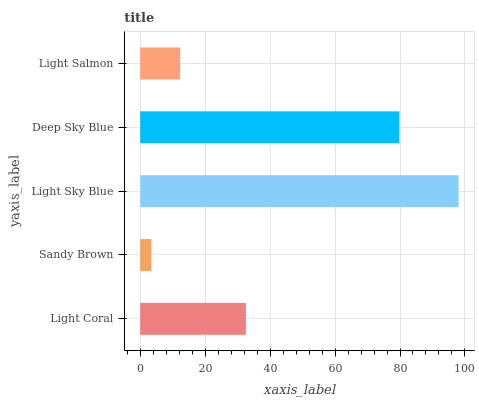Is Sandy Brown the minimum?
Answer yes or no. Yes. Is Light Sky Blue the maximum?
Answer yes or no. Yes. Is Light Sky Blue the minimum?
Answer yes or no. No. Is Sandy Brown the maximum?
Answer yes or no. No. Is Light Sky Blue greater than Sandy Brown?
Answer yes or no. Yes. Is Sandy Brown less than Light Sky Blue?
Answer yes or no. Yes. Is Sandy Brown greater than Light Sky Blue?
Answer yes or no. No. Is Light Sky Blue less than Sandy Brown?
Answer yes or no. No. Is Light Coral the high median?
Answer yes or no. Yes. Is Light Coral the low median?
Answer yes or no. Yes. Is Light Salmon the high median?
Answer yes or no. No. Is Light Sky Blue the low median?
Answer yes or no. No. 